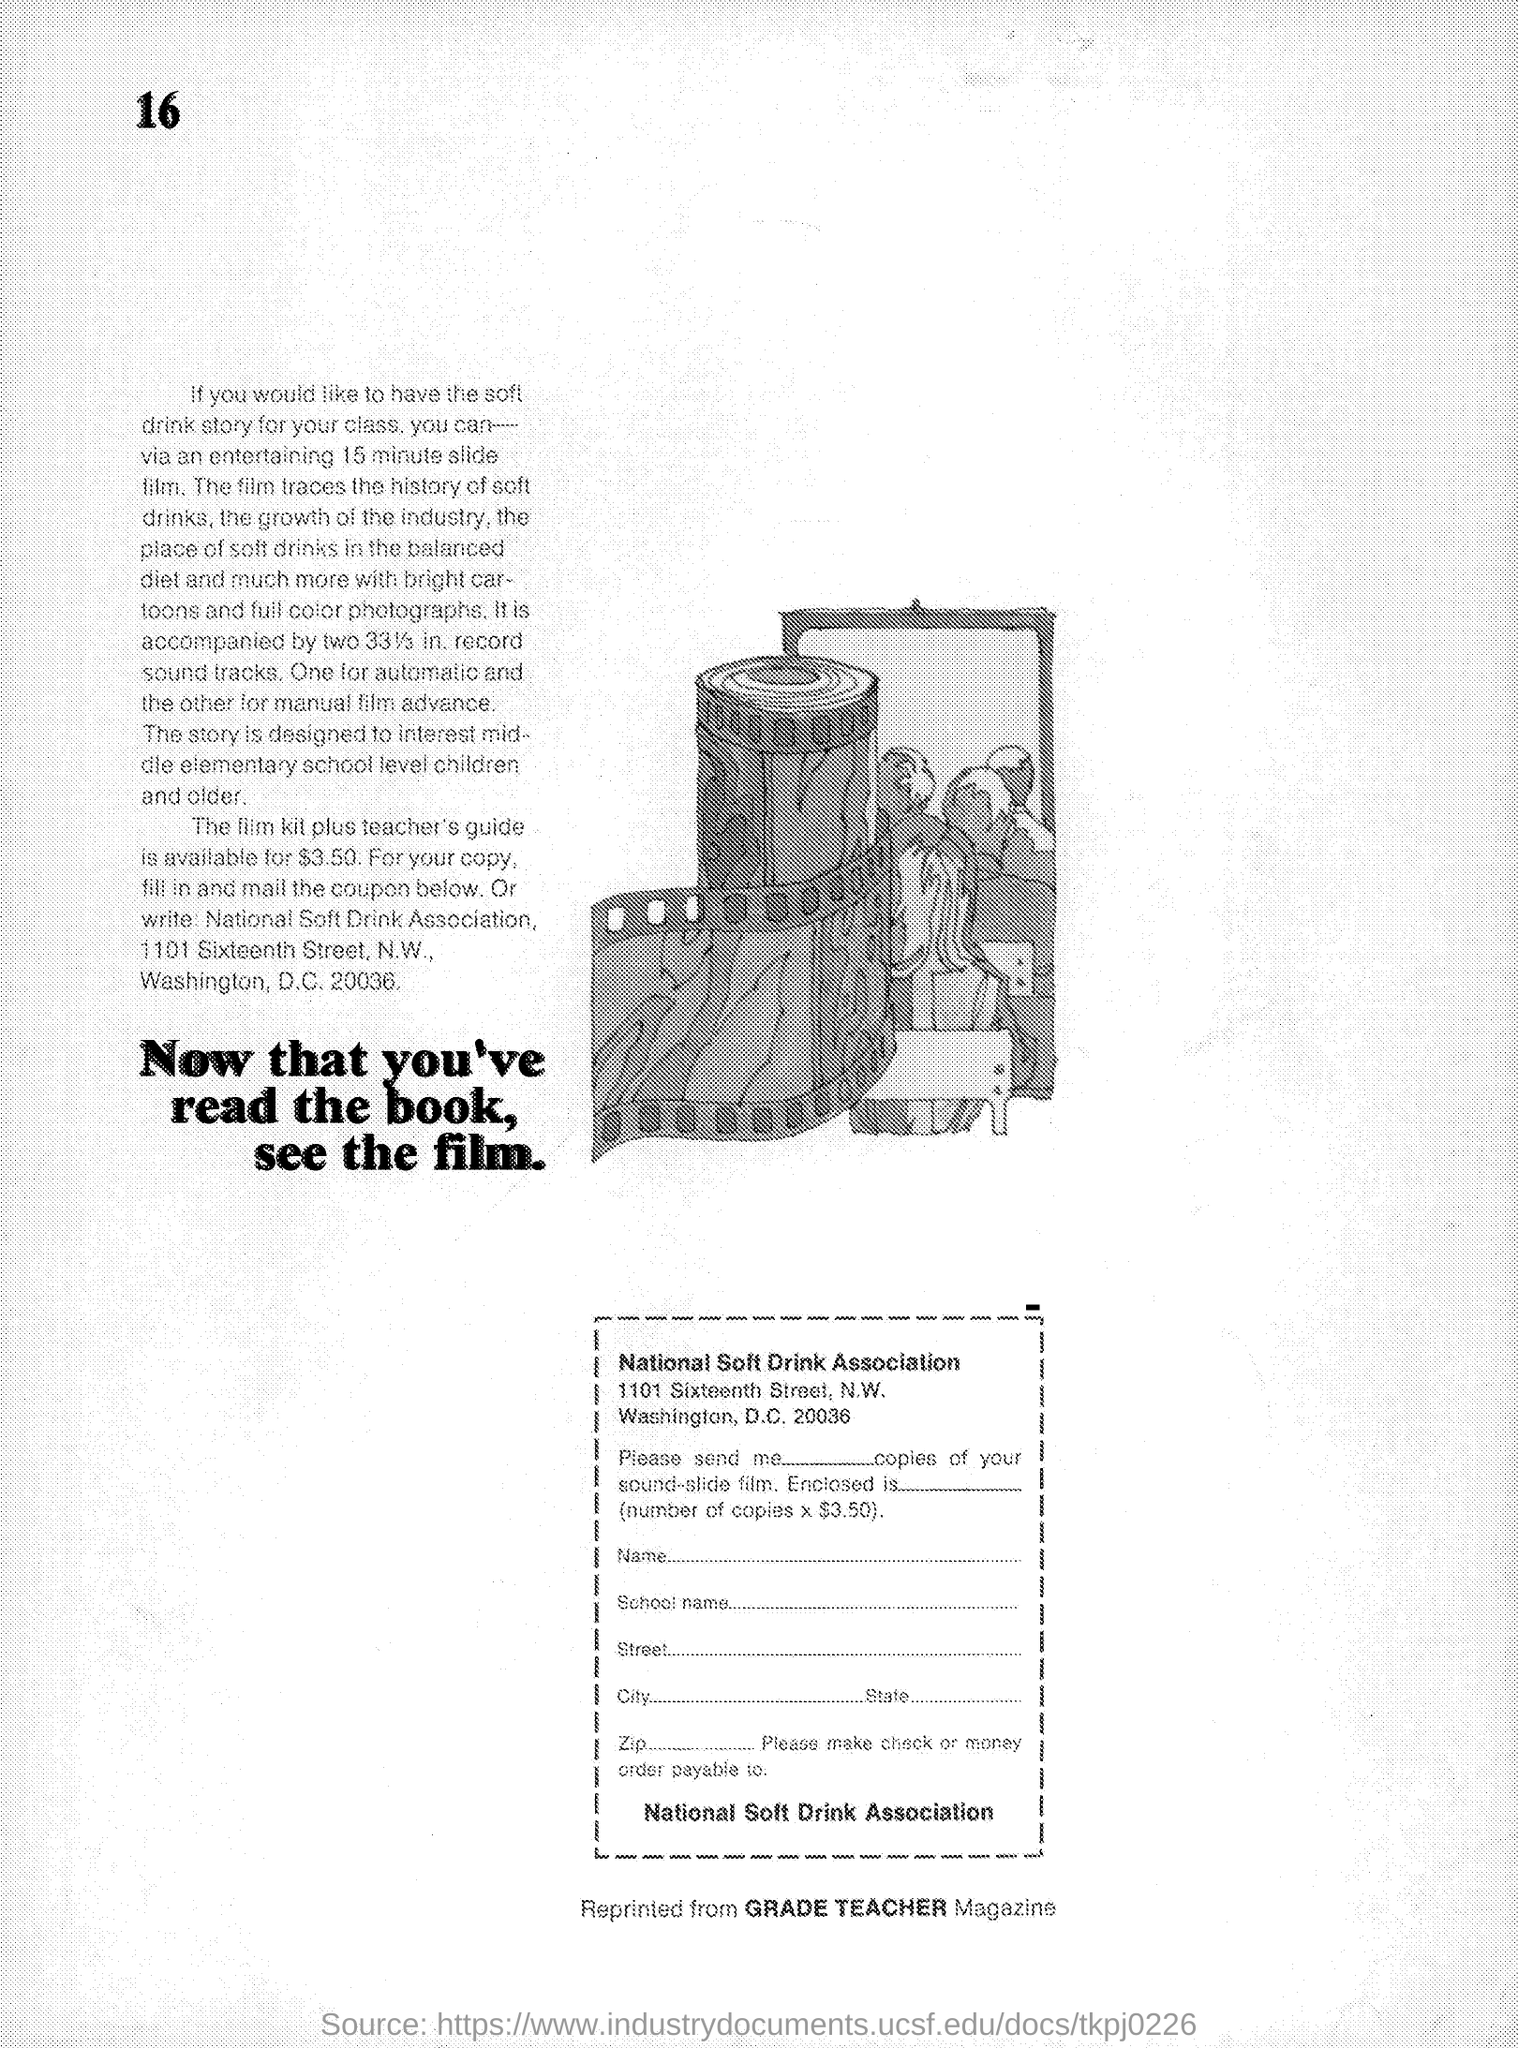Specify some key components in this picture. Our story is intended to captivate the interest of middle elementary school children and older. The "film kit plus teacher's guide" is available for a price of $3.50. 